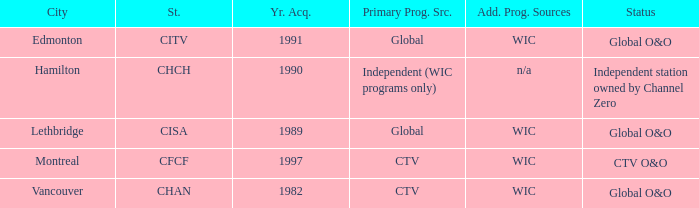How many channels were gained in 1997 1.0. 